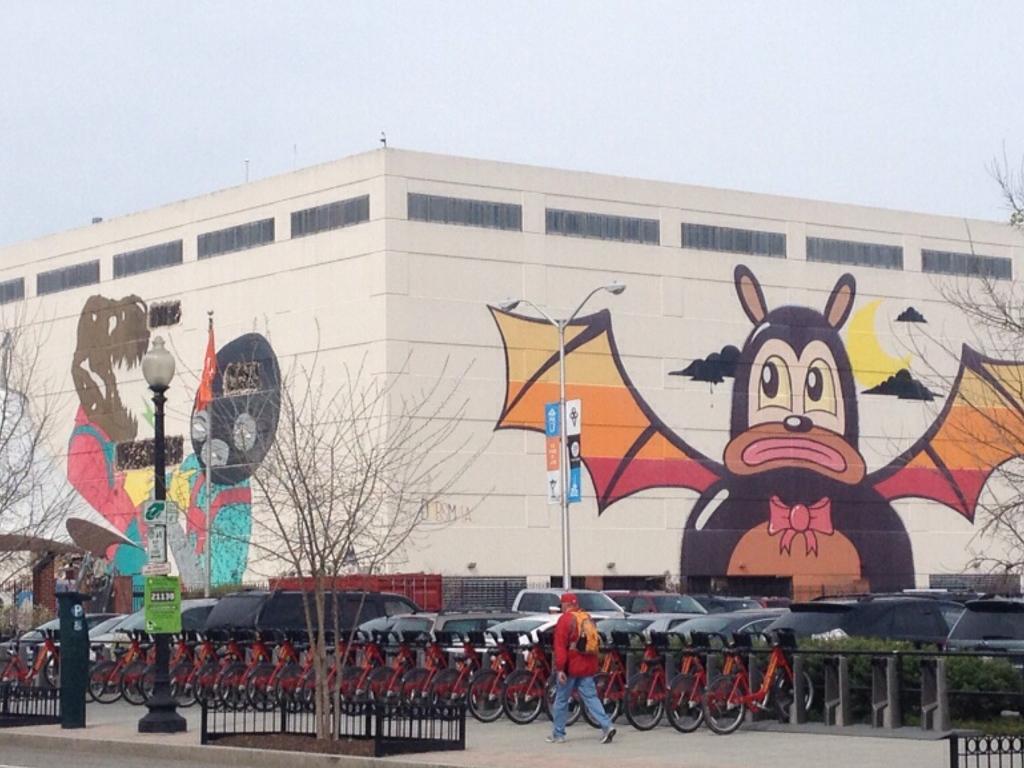In one or two sentences, can you explain what this image depicts? In the image I can see a building to which there are some paintings and also I can see some people, bicycles, cars and a fencing. 